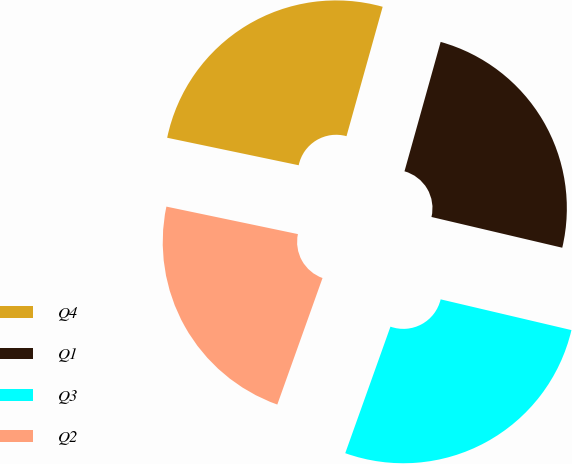Convert chart to OTSL. <chart><loc_0><loc_0><loc_500><loc_500><pie_chart><fcel>Q4<fcel>Q1<fcel>Q3<fcel>Q2<nl><fcel>26.06%<fcel>24.34%<fcel>26.79%<fcel>22.82%<nl></chart> 